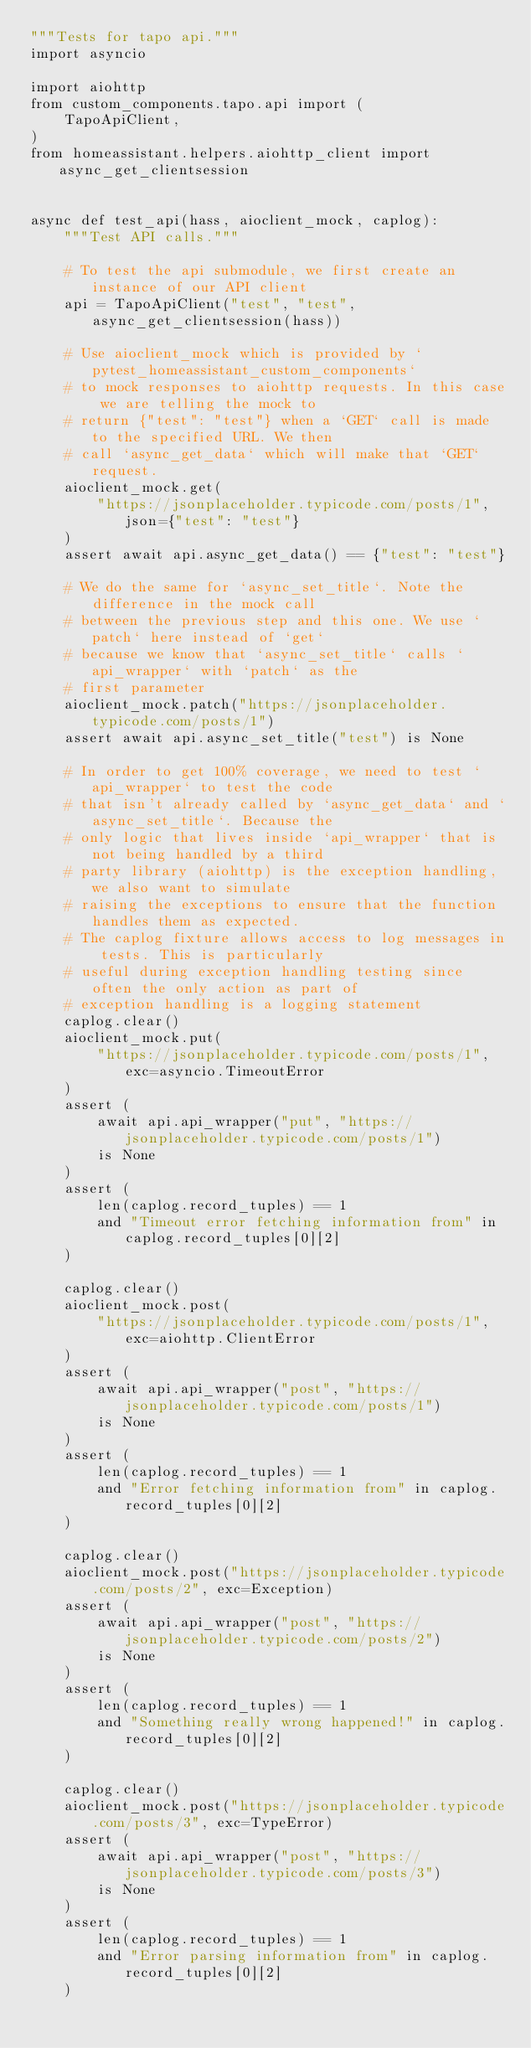<code> <loc_0><loc_0><loc_500><loc_500><_Python_>"""Tests for tapo api."""
import asyncio

import aiohttp
from custom_components.tapo.api import (
    TapoApiClient,
)
from homeassistant.helpers.aiohttp_client import async_get_clientsession


async def test_api(hass, aioclient_mock, caplog):
    """Test API calls."""

    # To test the api submodule, we first create an instance of our API client
    api = TapoApiClient("test", "test", async_get_clientsession(hass))

    # Use aioclient_mock which is provided by `pytest_homeassistant_custom_components`
    # to mock responses to aiohttp requests. In this case we are telling the mock to
    # return {"test": "test"} when a `GET` call is made to the specified URL. We then
    # call `async_get_data` which will make that `GET` request.
    aioclient_mock.get(
        "https://jsonplaceholder.typicode.com/posts/1", json={"test": "test"}
    )
    assert await api.async_get_data() == {"test": "test"}

    # We do the same for `async_set_title`. Note the difference in the mock call
    # between the previous step and this one. We use `patch` here instead of `get`
    # because we know that `async_set_title` calls `api_wrapper` with `patch` as the
    # first parameter
    aioclient_mock.patch("https://jsonplaceholder.typicode.com/posts/1")
    assert await api.async_set_title("test") is None

    # In order to get 100% coverage, we need to test `api_wrapper` to test the code
    # that isn't already called by `async_get_data` and `async_set_title`. Because the
    # only logic that lives inside `api_wrapper` that is not being handled by a third
    # party library (aiohttp) is the exception handling, we also want to simulate
    # raising the exceptions to ensure that the function handles them as expected.
    # The caplog fixture allows access to log messages in tests. This is particularly
    # useful during exception handling testing since often the only action as part of
    # exception handling is a logging statement
    caplog.clear()
    aioclient_mock.put(
        "https://jsonplaceholder.typicode.com/posts/1", exc=asyncio.TimeoutError
    )
    assert (
        await api.api_wrapper("put", "https://jsonplaceholder.typicode.com/posts/1")
        is None
    )
    assert (
        len(caplog.record_tuples) == 1
        and "Timeout error fetching information from" in caplog.record_tuples[0][2]
    )

    caplog.clear()
    aioclient_mock.post(
        "https://jsonplaceholder.typicode.com/posts/1", exc=aiohttp.ClientError
    )
    assert (
        await api.api_wrapper("post", "https://jsonplaceholder.typicode.com/posts/1")
        is None
    )
    assert (
        len(caplog.record_tuples) == 1
        and "Error fetching information from" in caplog.record_tuples[0][2]
    )

    caplog.clear()
    aioclient_mock.post("https://jsonplaceholder.typicode.com/posts/2", exc=Exception)
    assert (
        await api.api_wrapper("post", "https://jsonplaceholder.typicode.com/posts/2")
        is None
    )
    assert (
        len(caplog.record_tuples) == 1
        and "Something really wrong happened!" in caplog.record_tuples[0][2]
    )

    caplog.clear()
    aioclient_mock.post("https://jsonplaceholder.typicode.com/posts/3", exc=TypeError)
    assert (
        await api.api_wrapper("post", "https://jsonplaceholder.typicode.com/posts/3")
        is None
    )
    assert (
        len(caplog.record_tuples) == 1
        and "Error parsing information from" in caplog.record_tuples[0][2]
    )
</code> 